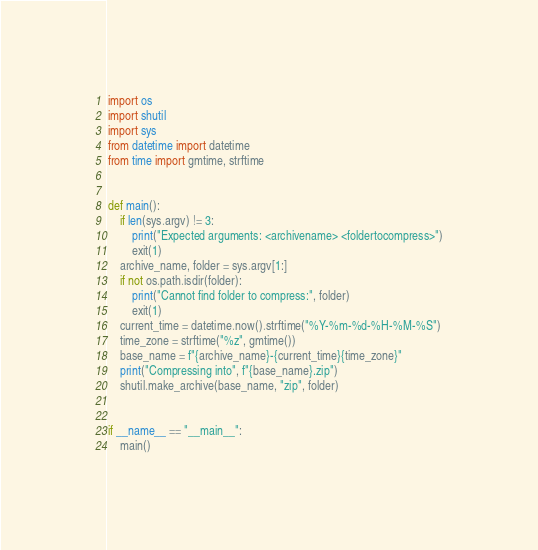<code> <loc_0><loc_0><loc_500><loc_500><_Python_>import os
import shutil
import sys
from datetime import datetime
from time import gmtime, strftime


def main():
    if len(sys.argv) != 3:
        print("Expected arguments: <archivename> <foldertocompress>")
        exit(1)
    archive_name, folder = sys.argv[1:]
    if not os.path.isdir(folder):
        print("Cannot find folder to compress:", folder)
        exit(1)
    current_time = datetime.now().strftime("%Y-%m-%d-%H-%M-%S")
    time_zone = strftime("%z", gmtime())
    base_name = f"{archive_name}-{current_time}{time_zone}"
    print("Compressing into", f"{base_name}.zip")
    shutil.make_archive(base_name, "zip", folder)


if __name__ == "__main__":
    main()
</code> 